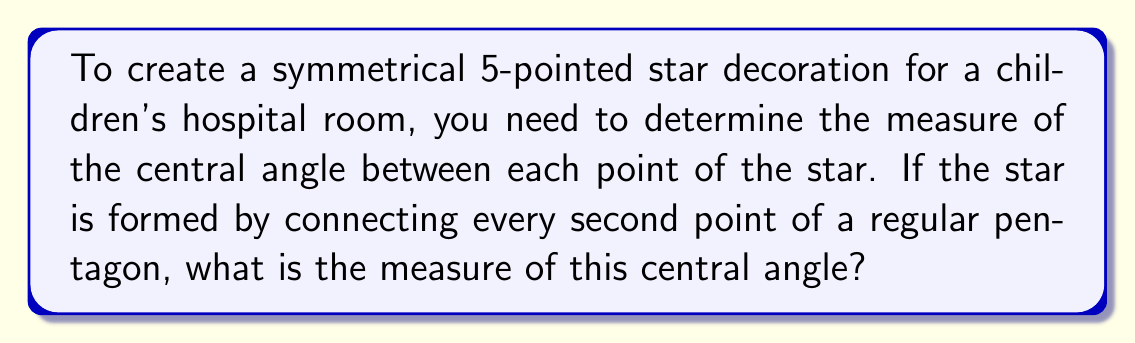What is the answer to this math problem? Let's approach this step-by-step:

1) A regular pentagon has 5 sides and 5 vertices.

2) The sum of interior angles of a pentagon is given by the formula:
   $$(n-2) \times 180°$$
   where n is the number of sides.
   For a pentagon, this is: $$(5-2) \times 180° = 540°$$

3) Each interior angle of a regular pentagon measures:
   $$\frac{540°}{5} = 108°$$

4) The central angle of a regular pentagon is:
   $$\frac{360°}{5} = 72°$$

5) In a 5-pointed star, we skip one vertex of the pentagon to create each point of the star. This means we're rotating by two central angles for each point of the star.

6) Therefore, the central angle between each point of the star is:
   $$72° \times 2 = 144°$$

[asy]
unitsize(50);
pair A = dir(90);
pair B = dir(90-72);
pair C = dir(90-2*72);
pair D = dir(90-3*72);
pair E = dir(90-4*72);

draw(A--C--E--B--D--A);
draw(circle(origin,1), dashed);
label("144°", origin, N);

dot(A); dot(B); dot(C); dot(D); dot(E);
[/asy]

This 144° angle ensures that the star will have perfect symmetry, making it an ideal decorative element for a children's hospital room, combining both mathematical precision and visual appeal.
Answer: 144° 